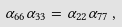Convert formula to latex. <formula><loc_0><loc_0><loc_500><loc_500>\alpha _ { 6 6 } \alpha _ { 3 3 } = \alpha _ { 2 2 } \alpha _ { 7 7 } \, ,</formula> 